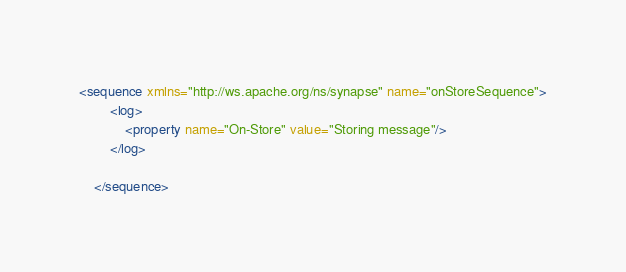<code> <loc_0><loc_0><loc_500><loc_500><_XML_><sequence xmlns="http://ws.apache.org/ns/synapse" name="onStoreSequence">
		<log>
			<property name="On-Store" value="Storing message"/>
		</log>

	</sequence></code> 